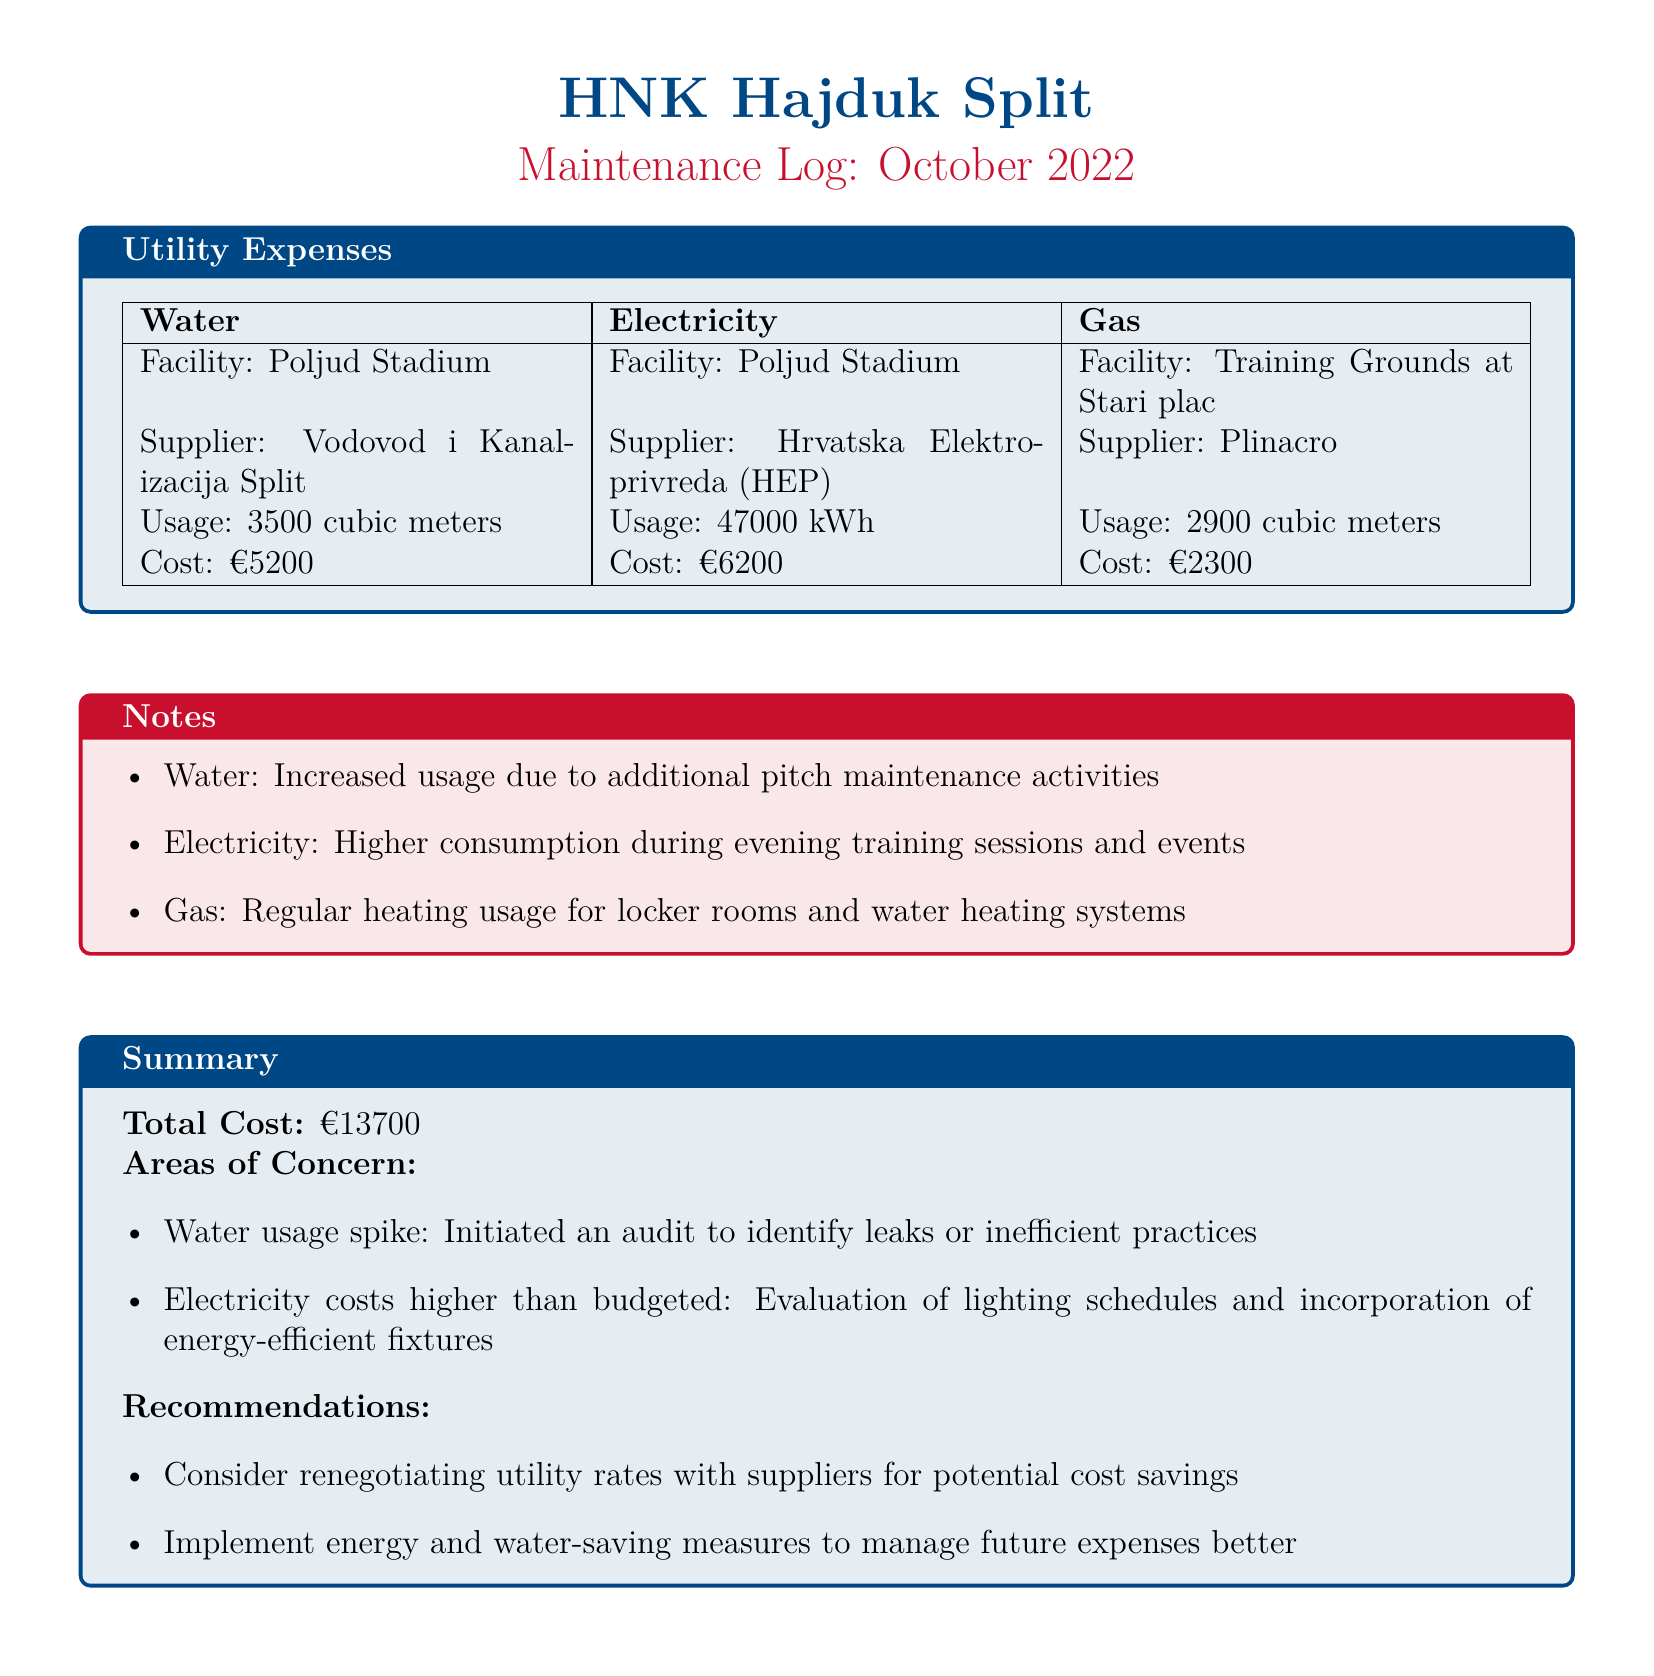what was the total cost of utility expenses? The total cost is summarized in the document, which states the total utility expenses for October 2022.
Answer: €13700 how much was spent on water? The document specifically lists the cost of water expenses as part of the utility expenses breakdown.
Answer: €5200 which facility had the highest electricity usage? The document identifies the facility with its corresponding usage for electricity.
Answer: Poljud Stadium what is the usage of gas in cubic meters? The document provides specific usage details for gas as part of the utility expenses.
Answer: 2900 cubic meters why did water usage increase? The document notes a specific reason for increased water usage in the notes section.
Answer: Additional pitch maintenance activities how much electricity was consumed in kWh? The document explicitly states the electricity consumption for October 2022.
Answer: 47000 kWh who is the supplier for gas? The document lists the name of the supplier responsible for gas services.
Answer: Plinacro what recommendation was made regarding utility rates? The document includes suggestions to improve financial management concerning utility expenses.
Answer: Consider renegotiating utility rates what was noted about electricity costs? The document highlights an area of concern related to electricity costs in the summary section.
Answer: Higher than budgeted 